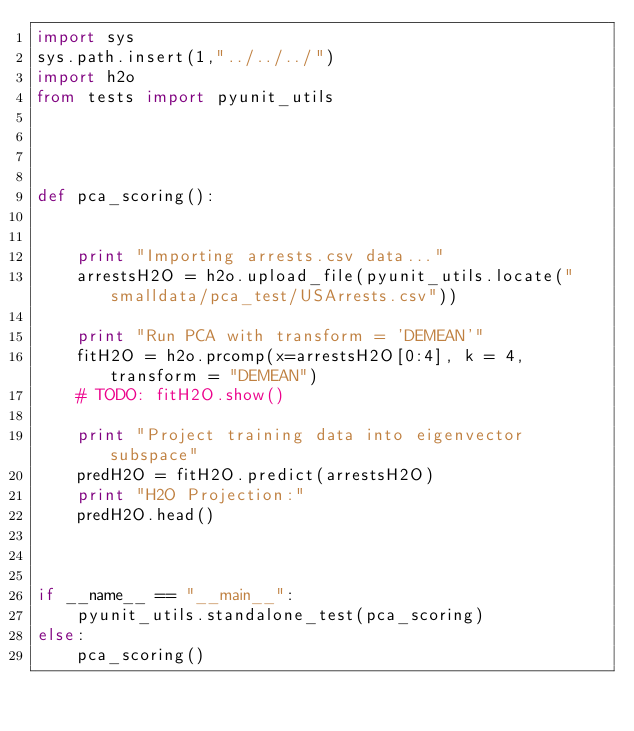<code> <loc_0><loc_0><loc_500><loc_500><_Python_>import sys
sys.path.insert(1,"../../../")
import h2o
from tests import pyunit_utils




def pca_scoring():


    print "Importing arrests.csv data..."
    arrestsH2O = h2o.upload_file(pyunit_utils.locate("smalldata/pca_test/USArrests.csv"))

    print "Run PCA with transform = 'DEMEAN'"
    fitH2O = h2o.prcomp(x=arrestsH2O[0:4], k = 4, transform = "DEMEAN")
    # TODO: fitH2O.show()

    print "Project training data into eigenvector subspace"
    predH2O = fitH2O.predict(arrestsH2O)
    print "H2O Projection:"
    predH2O.head()



if __name__ == "__main__":
    pyunit_utils.standalone_test(pca_scoring)
else:
    pca_scoring()
</code> 